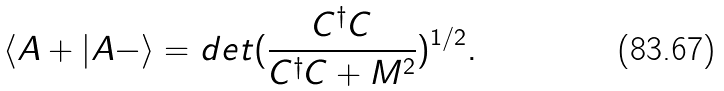<formula> <loc_0><loc_0><loc_500><loc_500>\langle A + | A - \rangle = d e t ( \frac { C ^ { \dagger } C } { C ^ { \dagger } C + M ^ { 2 } } ) ^ { 1 / 2 } .</formula> 